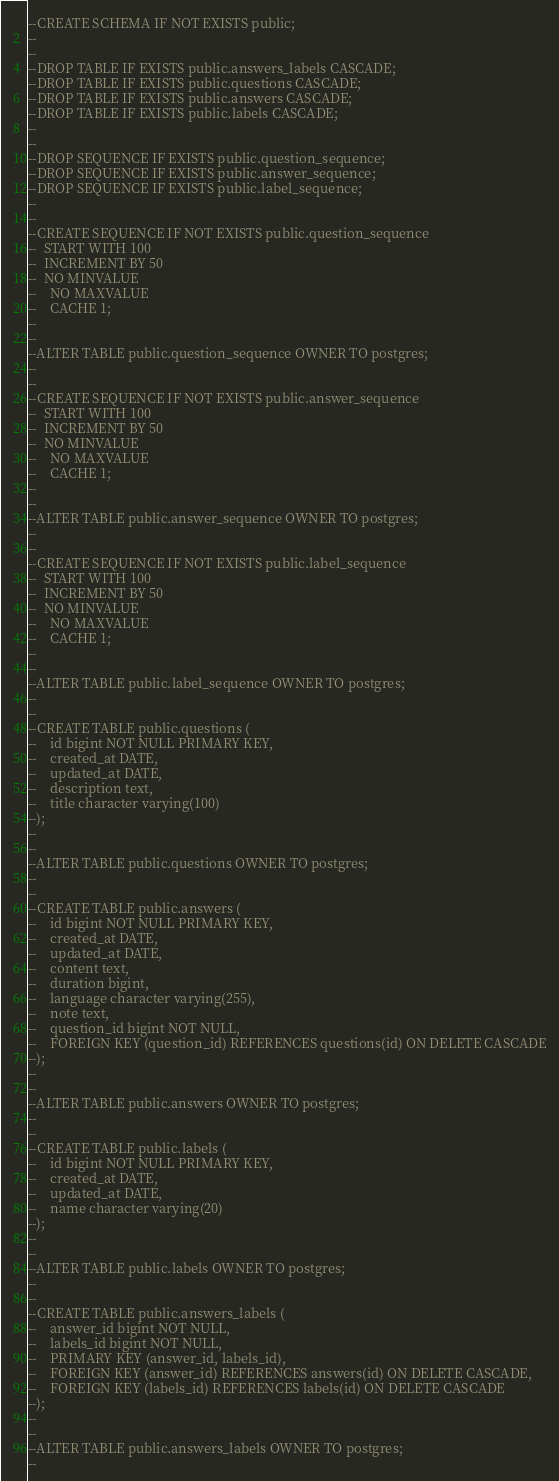Convert code to text. <code><loc_0><loc_0><loc_500><loc_500><_SQL_>--CREATE SCHEMA IF NOT EXISTS public;
--
--
--DROP TABLE IF EXISTS public.answers_labels CASCADE;
--DROP TABLE IF EXISTS public.questions CASCADE;
--DROP TABLE IF EXISTS public.answers CASCADE;
--DROP TABLE IF EXISTS public.labels CASCADE;
--
--
--DROP SEQUENCE IF EXISTS public.question_sequence;
--DROP SEQUENCE IF EXISTS public.answer_sequence;
--DROP SEQUENCE IF EXISTS public.label_sequence;
--
--
--CREATE SEQUENCE IF NOT EXISTS public.question_sequence
--	START WITH 100
--	INCREMENT BY 50
--	NO MINVALUE
--    NO MAXVALUE
--    CACHE 1;
--
--
--ALTER TABLE public.question_sequence OWNER TO postgres;
--
--
--CREATE SEQUENCE IF NOT EXISTS public.answer_sequence
--	START WITH 100
--	INCREMENT BY 50
--	NO MINVALUE
--    NO MAXVALUE
--    CACHE 1;
--
--
--ALTER TABLE public.answer_sequence OWNER TO postgres;
--
--
--CREATE SEQUENCE IF NOT EXISTS public.label_sequence
--	START WITH 100
--	INCREMENT BY 50
--	NO MINVALUE
--    NO MAXVALUE
--    CACHE 1;
--
--
--ALTER TABLE public.label_sequence OWNER TO postgres;
--
--
--CREATE TABLE public.questions (
--    id bigint NOT NULL PRIMARY KEY,
--    created_at DATE,
--    updated_at DATE,
--    description text,
--    title character varying(100)
--);
--
--
--ALTER TABLE public.questions OWNER TO postgres;
--
--
--CREATE TABLE public.answers (
--    id bigint NOT NULL PRIMARY KEY,
--    created_at DATE,
--    updated_at DATE,
--    content text,
--    duration bigint,
--    language character varying(255),
--    note text,
--    question_id bigint NOT NULL,
--    FOREIGN KEY (question_id) REFERENCES questions(id) ON DELETE CASCADE
--);
--
--
--ALTER TABLE public.answers OWNER TO postgres;
--
--
--CREATE TABLE public.labels (
--    id bigint NOT NULL PRIMARY KEY,
--    created_at DATE,
--    updated_at DATE,
--    name character varying(20)
--);
--
--
--ALTER TABLE public.labels OWNER TO postgres;
--
--
--CREATE TABLE public.answers_labels (
--    answer_id bigint NOT NULL,
--    labels_id bigint NOT NULL,
--    PRIMARY KEY (answer_id, labels_id),
--    FOREIGN KEY (answer_id) REFERENCES answers(id) ON DELETE CASCADE,
--    FOREIGN KEY (labels_id) REFERENCES labels(id) ON DELETE CASCADE
--);
--
--
--ALTER TABLE public.answers_labels OWNER TO postgres;
--
</code> 